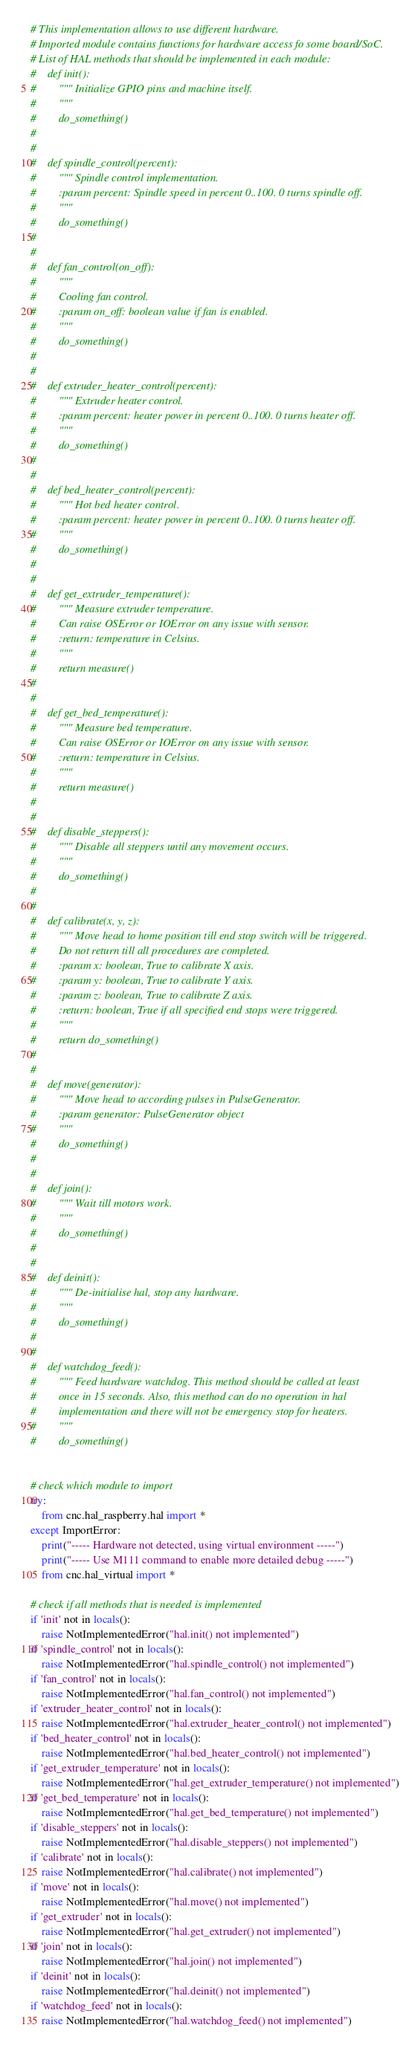<code> <loc_0><loc_0><loc_500><loc_500><_Python_># This implementation allows to use different hardware.
# Imported module contains functions for hardware access fo some board/SoC.
# List of HAL methods that should be implemented in each module:
#    def init():
#        """ Initialize GPIO pins and machine itself.
#        """
#        do_something()
#
#
#    def spindle_control(percent):
#        """ Spindle control implementation.
#        :param percent: Spindle speed in percent 0..100. 0 turns spindle off.
#        """
#        do_something()
#
#
#    def fan_control(on_off):
#        """
#        Cooling fan control.
#        :param on_off: boolean value if fan is enabled.
#        """
#        do_something()
#
#
#    def extruder_heater_control(percent):
#        """ Extruder heater control.
#        :param percent: heater power in percent 0..100. 0 turns heater off.
#        """
#        do_something()
#
#
#    def bed_heater_control(percent):
#        """ Hot bed heater control.
#        :param percent: heater power in percent 0..100. 0 turns heater off.
#        """
#        do_something()
#
#
#    def get_extruder_temperature():
#        """ Measure extruder temperature.
#        Can raise OSError or IOError on any issue with sensor.
#        :return: temperature in Celsius.
#        """
#        return measure()
#
#
#    def get_bed_temperature():
#        """ Measure bed temperature.
#        Can raise OSError or IOError on any issue with sensor.
#        :return: temperature in Celsius.
#        """
#        return measure()
#
#
#    def disable_steppers():
#        """ Disable all steppers until any movement occurs.
#        """
#        do_something()
#
#
#    def calibrate(x, y, z):
#        """ Move head to home position till end stop switch will be triggered.
#        Do not return till all procedures are completed.
#        :param x: boolean, True to calibrate X axis.
#        :param y: boolean, True to calibrate Y axis.
#        :param z: boolean, True to calibrate Z axis.
#        :return: boolean, True if all specified end stops were triggered.
#        """
#        return do_something()
#
#
#    def move(generator):
#        """ Move head to according pulses in PulseGenerator.
#        :param generator: PulseGenerator object
#        """
#        do_something()
#
#
#    def join():
#        """ Wait till motors work.
#        """
#        do_something()
#
#
#    def deinit():
#        """ De-initialise hal, stop any hardware.
#        """
#        do_something()
#
#
#    def watchdog_feed():
#        """ Feed hardware watchdog. This method should be called at least
#        once in 15 seconds. Also, this method can do no operation in hal
#        implementation and there will not be emergency stop for heaters.
#        """
#        do_something()


# check which module to import
try:
    from cnc.hal_raspberry.hal import *
except ImportError:
    print("----- Hardware not detected, using virtual environment -----")
    print("----- Use M111 command to enable more detailed debug -----")
    from cnc.hal_virtual import *

# check if all methods that is needed is implemented
if 'init' not in locals():
    raise NotImplementedError("hal.init() not implemented")
if 'spindle_control' not in locals():
    raise NotImplementedError("hal.spindle_control() not implemented")
if 'fan_control' not in locals():
    raise NotImplementedError("hal.fan_control() not implemented")
if 'extruder_heater_control' not in locals():
    raise NotImplementedError("hal.extruder_heater_control() not implemented")
if 'bed_heater_control' not in locals():
    raise NotImplementedError("hal.bed_heater_control() not implemented")
if 'get_extruder_temperature' not in locals():
    raise NotImplementedError("hal.get_extruder_temperature() not implemented")
if 'get_bed_temperature' not in locals():
    raise NotImplementedError("hal.get_bed_temperature() not implemented")
if 'disable_steppers' not in locals():
    raise NotImplementedError("hal.disable_steppers() not implemented")
if 'calibrate' not in locals():
    raise NotImplementedError("hal.calibrate() not implemented")
if 'move' not in locals():
    raise NotImplementedError("hal.move() not implemented")
if 'get_extruder' not in locals():
    raise NotImplementedError("hal.get_extruder() not implemented")
if 'join' not in locals():
    raise NotImplementedError("hal.join() not implemented")
if 'deinit' not in locals():
    raise NotImplementedError("hal.deinit() not implemented")
if 'watchdog_feed' not in locals():
    raise NotImplementedError("hal.watchdog_feed() not implemented")
</code> 